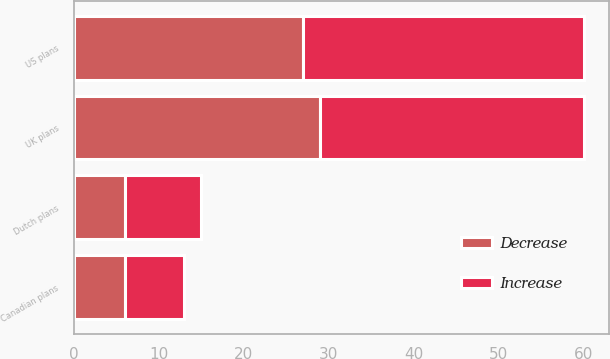Convert chart. <chart><loc_0><loc_0><loc_500><loc_500><stacked_bar_chart><ecel><fcel>US plans<fcel>UK plans<fcel>Dutch plans<fcel>Canadian plans<nl><fcel>Decrease<fcel>27<fcel>29<fcel>6<fcel>6<nl><fcel>Increase<fcel>33<fcel>31<fcel>9<fcel>7<nl></chart> 